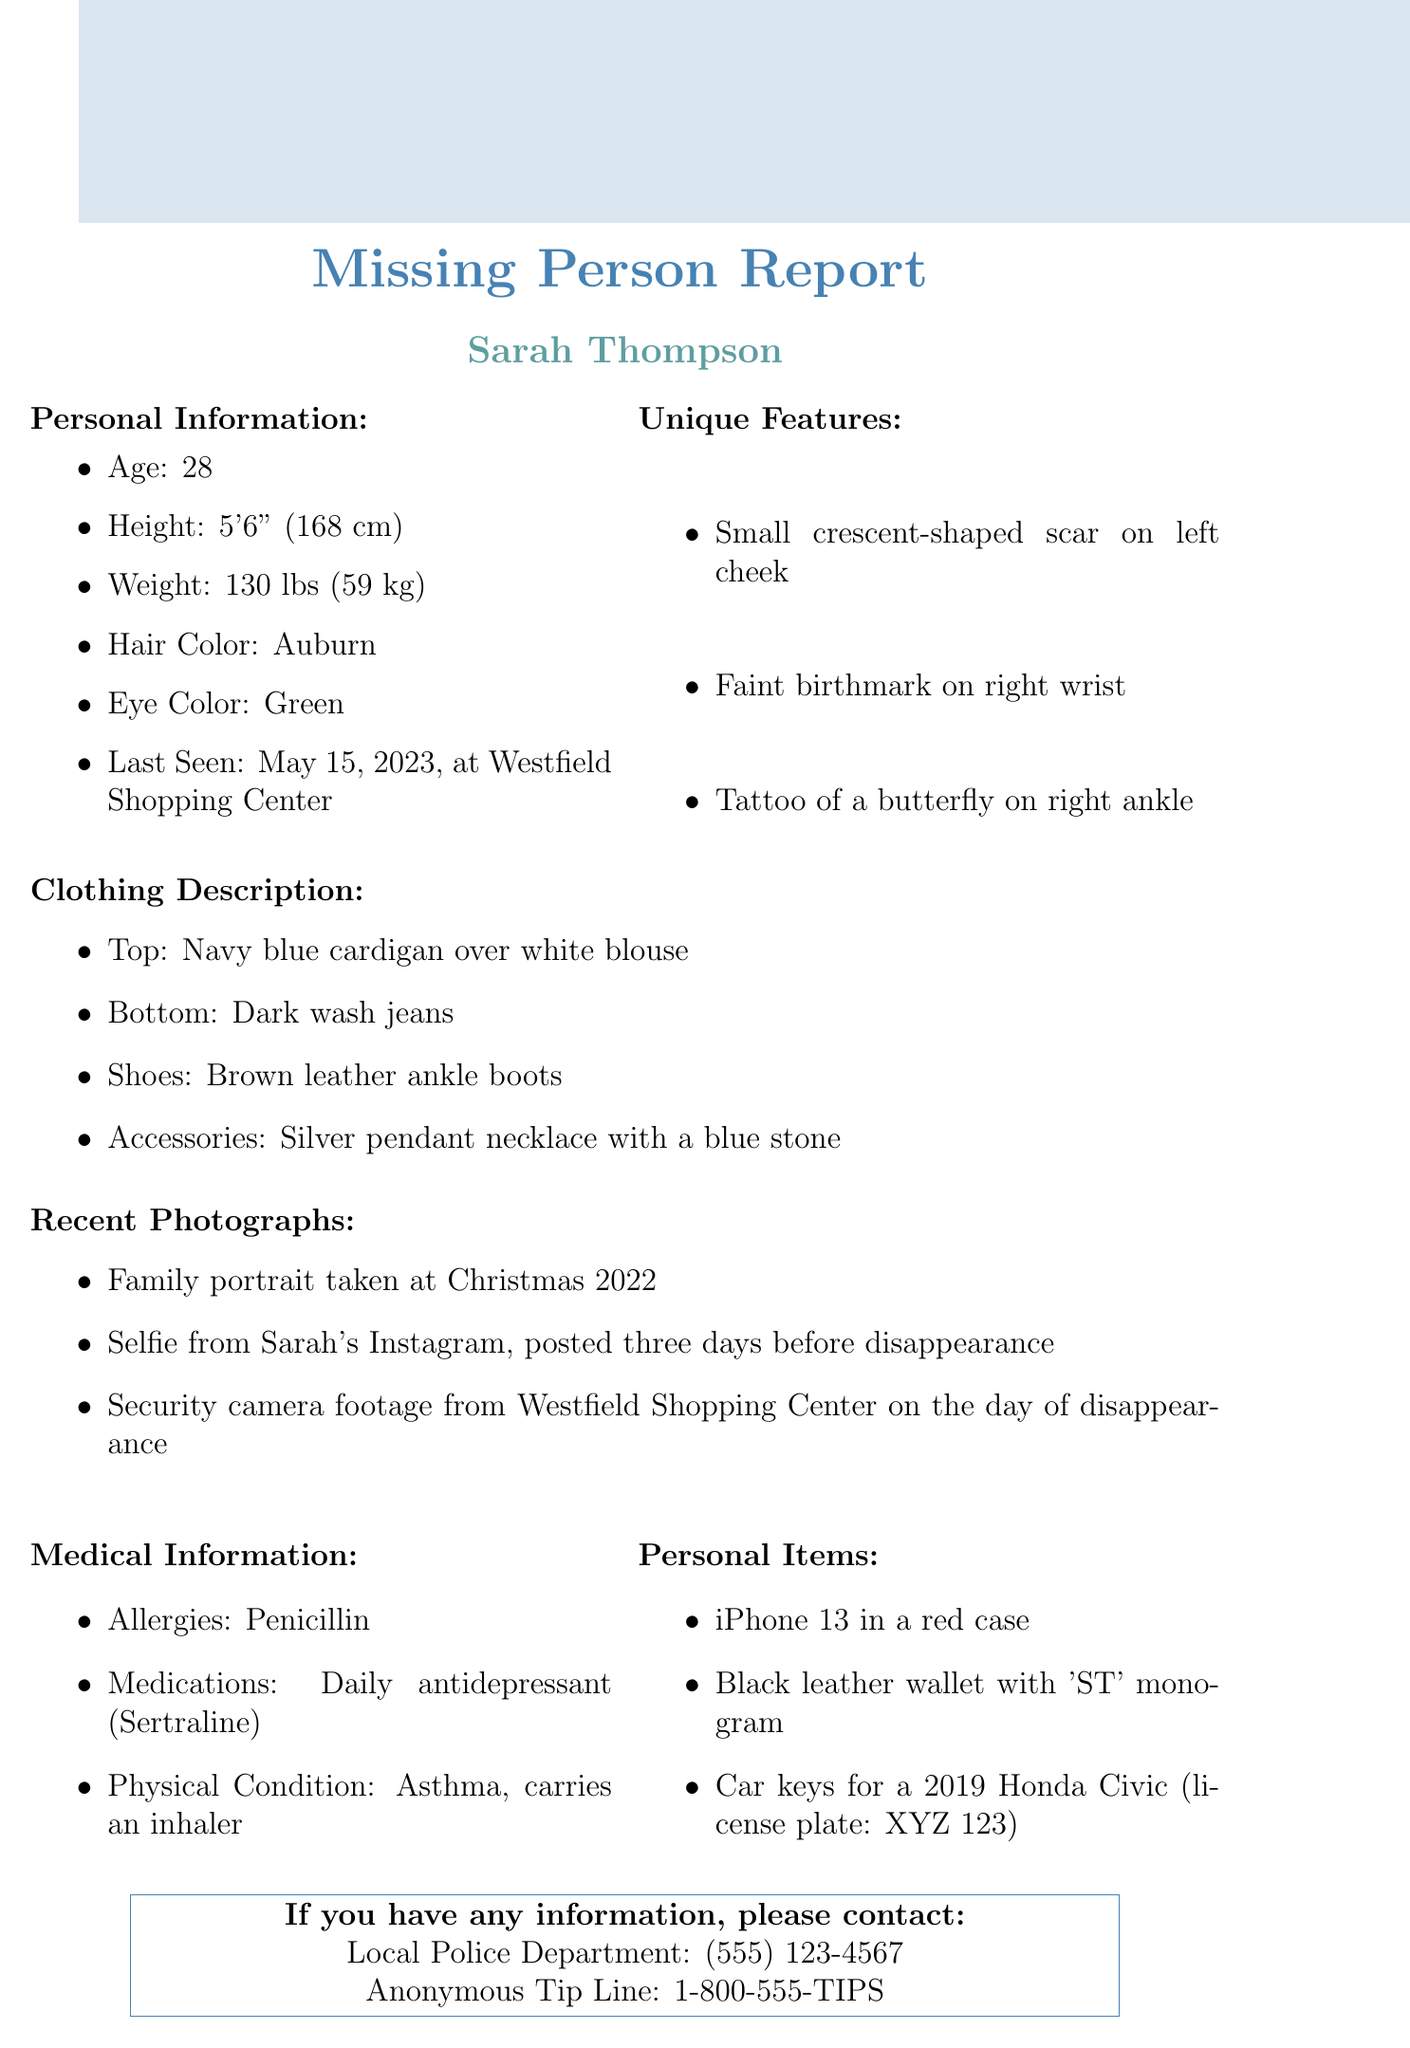What is the missing person's name? The name of the missing person is stated in the document as "Sarah Thompson."
Answer: Sarah Thompson How old is Sarah Thompson? The age of Sarah Thompson is mentioned in the document as 28.
Answer: 28 What is Sarah's eye color? Eye color information is provided in the document, indicating her eye color is green.
Answer: Green Where was Sarah last seen? The document specifies that Sarah was last seen at "Westfield Shopping Center."
Answer: Westfield Shopping Center What unique feature does Sarah have on her cheek? The document mentions a "small crescent-shaped scar on left cheek" as a unique feature.
Answer: small crescent-shaped scar What type of shoes was Sarah wearing last? The clothing description provides details stating she was wearing "brown leather ankle boots."
Answer: brown leather ankle boots Which medication does Sarah take daily? The medical information states that Sarah takes "Sertraline" daily.
Answer: Sertraline What color is Sarah's iPhone case? The document specifies that Sarah's iPhone is in a "red case."
Answer: red How many photographs are listed in the recent photographs? The document lists three recent photographs of Sarah.
Answer: three What is the license plate number of Sarah's car? The personal items section includes the license plate number "XYZ 123" for her car.
Answer: XYZ 123 